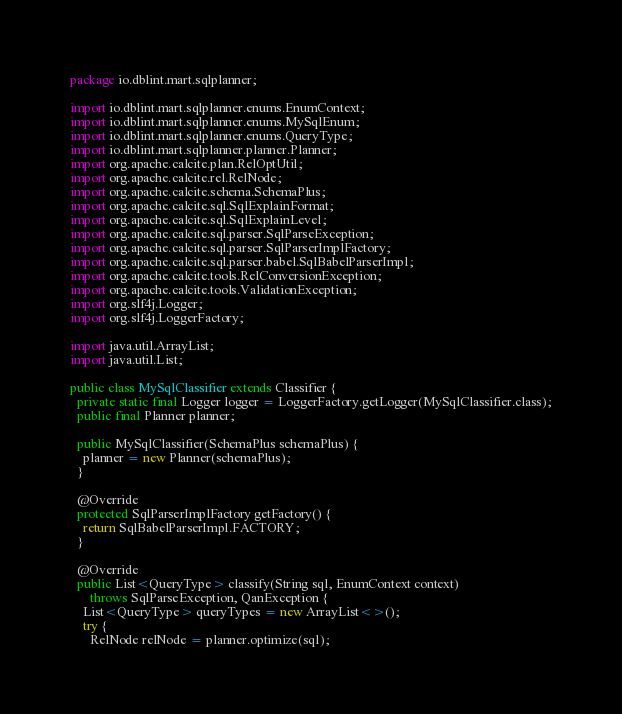Convert code to text. <code><loc_0><loc_0><loc_500><loc_500><_Java_>package io.dblint.mart.sqlplanner;

import io.dblint.mart.sqlplanner.enums.EnumContext;
import io.dblint.mart.sqlplanner.enums.MySqlEnum;
import io.dblint.mart.sqlplanner.enums.QueryType;
import io.dblint.mart.sqlplanner.planner.Planner;
import org.apache.calcite.plan.RelOptUtil;
import org.apache.calcite.rel.RelNode;
import org.apache.calcite.schema.SchemaPlus;
import org.apache.calcite.sql.SqlExplainFormat;
import org.apache.calcite.sql.SqlExplainLevel;
import org.apache.calcite.sql.parser.SqlParseException;
import org.apache.calcite.sql.parser.SqlParserImplFactory;
import org.apache.calcite.sql.parser.babel.SqlBabelParserImpl;
import org.apache.calcite.tools.RelConversionException;
import org.apache.calcite.tools.ValidationException;
import org.slf4j.Logger;
import org.slf4j.LoggerFactory;

import java.util.ArrayList;
import java.util.List;

public class MySqlClassifier extends Classifier {
  private static final Logger logger = LoggerFactory.getLogger(MySqlClassifier.class);
  public final Planner planner;

  public MySqlClassifier(SchemaPlus schemaPlus) {
    planner = new Planner(schemaPlus);
  }

  @Override
  protected SqlParserImplFactory getFactory() {
    return SqlBabelParserImpl.FACTORY;
  }

  @Override
  public List<QueryType> classify(String sql, EnumContext context)
      throws SqlParseException, QanException {
    List<QueryType> queryTypes = new ArrayList<>();
    try {
      RelNode relNode = planner.optimize(sql);
</code> 